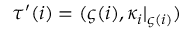Convert formula to latex. <formula><loc_0><loc_0><loc_500><loc_500>\tau ^ { \prime } ( i ) = ( \varsigma ( i ) , \kappa _ { i } | _ { \varsigma ( i ) } )</formula> 